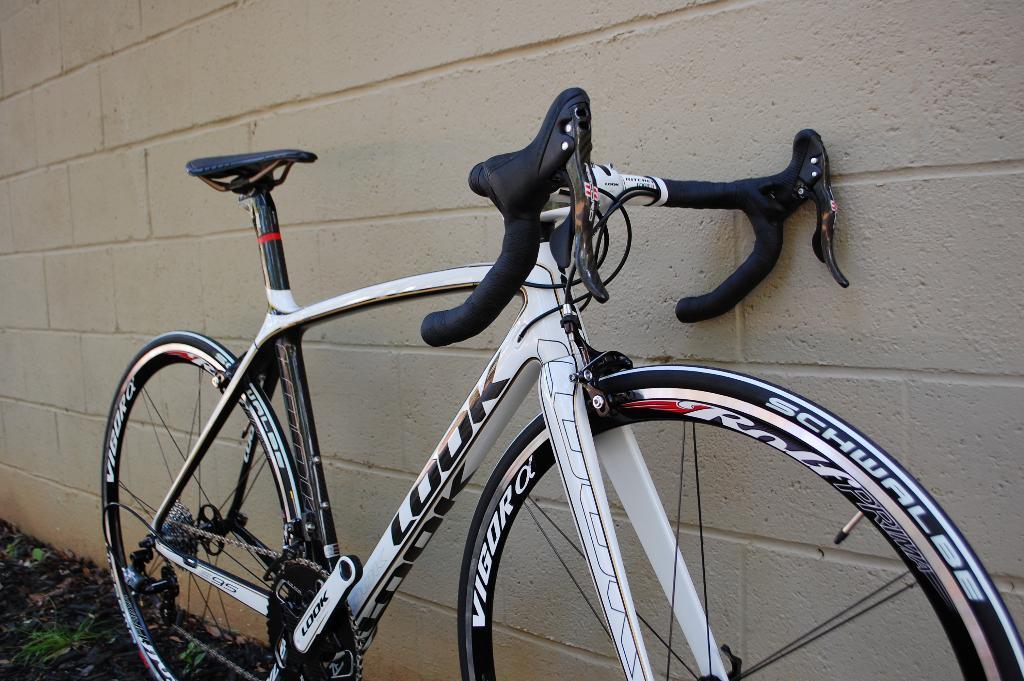Could you give a brief overview of what you see in this image? In this image we can see a bicycle placed beside a wall. 